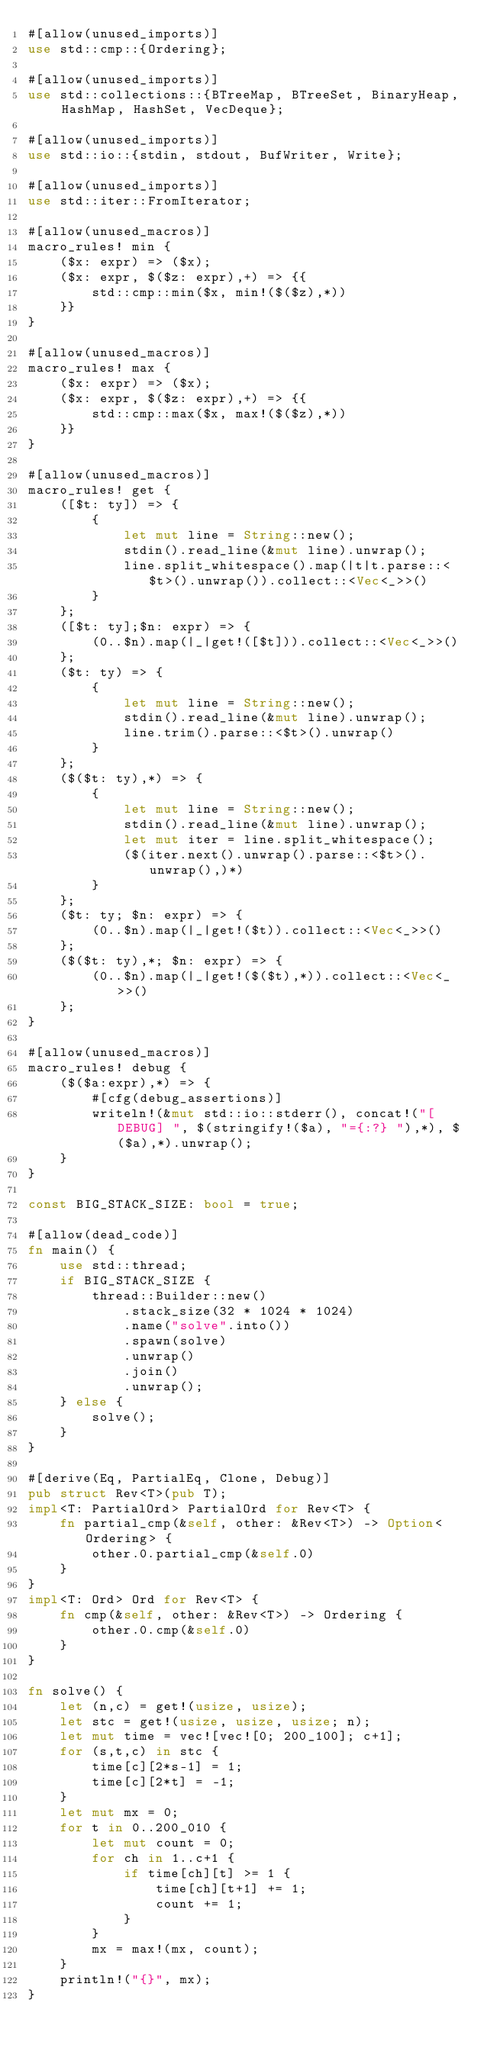Convert code to text. <code><loc_0><loc_0><loc_500><loc_500><_Rust_>#[allow(unused_imports)]
use std::cmp::{Ordering};

#[allow(unused_imports)]
use std::collections::{BTreeMap, BTreeSet, BinaryHeap, HashMap, HashSet, VecDeque};

#[allow(unused_imports)]
use std::io::{stdin, stdout, BufWriter, Write};

#[allow(unused_imports)]
use std::iter::FromIterator;

#[allow(unused_macros)]
macro_rules! min {
    ($x: expr) => ($x);
    ($x: expr, $($z: expr),+) => {{
        std::cmp::min($x, min!($($z),*))
    }}
}

#[allow(unused_macros)]
macro_rules! max {
    ($x: expr) => ($x);
    ($x: expr, $($z: expr),+) => {{
        std::cmp::max($x, max!($($z),*))
    }}
}

#[allow(unused_macros)]
macro_rules! get { 
    ([$t: ty]) => { 
        { 
            let mut line = String::new(); 
            stdin().read_line(&mut line).unwrap(); 
            line.split_whitespace().map(|t|t.parse::<$t>().unwrap()).collect::<Vec<_>>()
        }
    };
    ([$t: ty];$n: expr) => {
        (0..$n).map(|_|get!([$t])).collect::<Vec<_>>()
    };
    ($t: ty) => {
        {
            let mut line = String::new();
            stdin().read_line(&mut line).unwrap();
            line.trim().parse::<$t>().unwrap()
        }
    };
    ($($t: ty),*) => {
        { 
            let mut line = String::new();
            stdin().read_line(&mut line).unwrap();
            let mut iter = line.split_whitespace();
            ($(iter.next().unwrap().parse::<$t>().unwrap(),)*)
        }
    };
    ($t: ty; $n: expr) => {
        (0..$n).map(|_|get!($t)).collect::<Vec<_>>()
    };
    ($($t: ty),*; $n: expr) => {
        (0..$n).map(|_|get!($($t),*)).collect::<Vec<_>>()
    };
}

#[allow(unused_macros)]
macro_rules! debug {
    ($($a:expr),*) => {
        #[cfg(debug_assertions)]
        writeln!(&mut std::io::stderr(), concat!("[DEBUG] ", $(stringify!($a), "={:?} "),*), $($a),*).unwrap();
    }
}

const BIG_STACK_SIZE: bool = true;

#[allow(dead_code)]
fn main() {
    use std::thread;
    if BIG_STACK_SIZE {
        thread::Builder::new()
            .stack_size(32 * 1024 * 1024)
            .name("solve".into())
            .spawn(solve)
            .unwrap()
            .join()
            .unwrap();
    } else {
        solve();
    }
}

#[derive(Eq, PartialEq, Clone, Debug)]
pub struct Rev<T>(pub T);
impl<T: PartialOrd> PartialOrd for Rev<T> {
    fn partial_cmp(&self, other: &Rev<T>) -> Option<Ordering> {
        other.0.partial_cmp(&self.0)
    }
}
impl<T: Ord> Ord for Rev<T> {
    fn cmp(&self, other: &Rev<T>) -> Ordering {
        other.0.cmp(&self.0)
    }
}

fn solve() {
    let (n,c) = get!(usize, usize);
    let stc = get!(usize, usize, usize; n);
    let mut time = vec![vec![0; 200_100]; c+1];
    for (s,t,c) in stc {
        time[c][2*s-1] = 1;
        time[c][2*t] = -1;
    }
    let mut mx = 0;
    for t in 0..200_010 {
        let mut count = 0;
        for ch in 1..c+1 {
            if time[ch][t] >= 1 {
                time[ch][t+1] += 1;
                count += 1;
            }
        }
        mx = max!(mx, count);
    }
    println!("{}", mx);
}
</code> 